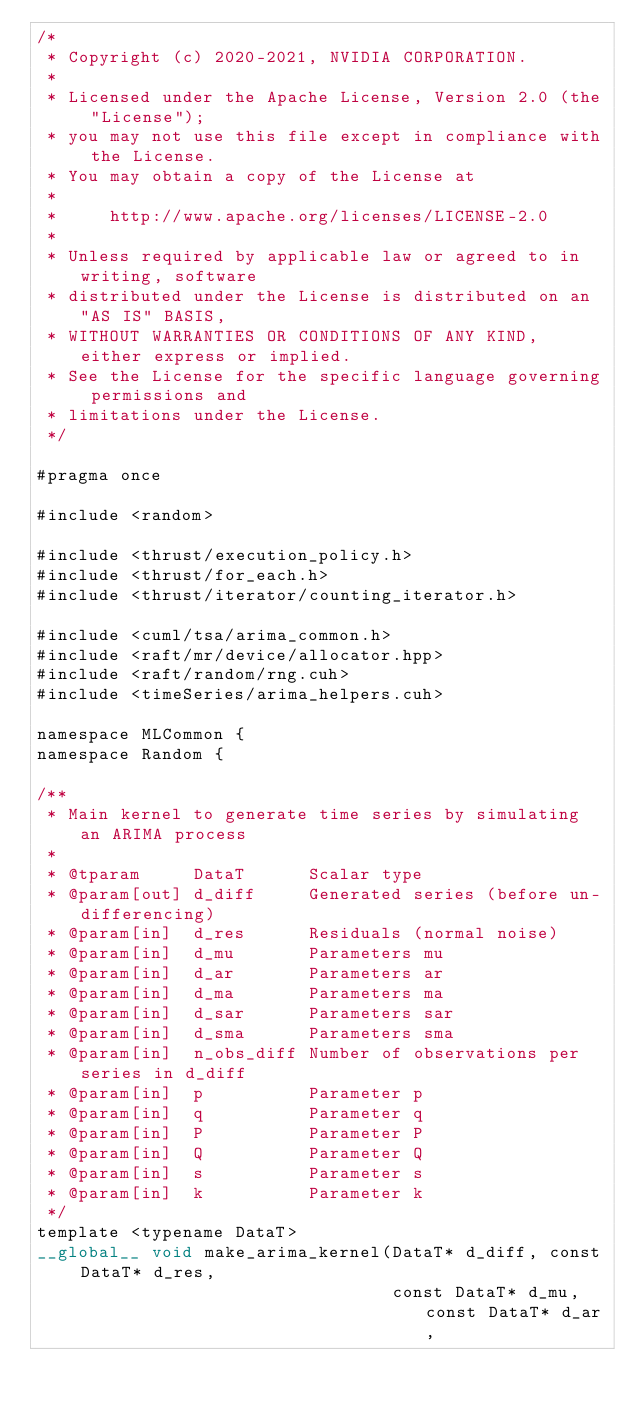<code> <loc_0><loc_0><loc_500><loc_500><_Cuda_>/*
 * Copyright (c) 2020-2021, NVIDIA CORPORATION.
 *
 * Licensed under the Apache License, Version 2.0 (the "License");
 * you may not use this file except in compliance with the License.
 * You may obtain a copy of the License at
 *
 *     http://www.apache.org/licenses/LICENSE-2.0
 *
 * Unless required by applicable law or agreed to in writing, software
 * distributed under the License is distributed on an "AS IS" BASIS,
 * WITHOUT WARRANTIES OR CONDITIONS OF ANY KIND, either express or implied.
 * See the License for the specific language governing permissions and
 * limitations under the License.
 */

#pragma once

#include <random>

#include <thrust/execution_policy.h>
#include <thrust/for_each.h>
#include <thrust/iterator/counting_iterator.h>

#include <cuml/tsa/arima_common.h>
#include <raft/mr/device/allocator.hpp>
#include <raft/random/rng.cuh>
#include <timeSeries/arima_helpers.cuh>

namespace MLCommon {
namespace Random {

/**
 * Main kernel to generate time series by simulating an ARIMA process
 *
 * @tparam     DataT      Scalar type
 * @param[out] d_diff     Generated series (before un-differencing)
 * @param[in]  d_res      Residuals (normal noise)
 * @param[in]  d_mu       Parameters mu
 * @param[in]  d_ar       Parameters ar
 * @param[in]  d_ma       Parameters ma
 * @param[in]  d_sar      Parameters sar
 * @param[in]  d_sma      Parameters sma
 * @param[in]  n_obs_diff Number of observations per series in d_diff
 * @param[in]  p          Parameter p
 * @param[in]  q          Parameter q
 * @param[in]  P          Parameter P
 * @param[in]  Q          Parameter Q
 * @param[in]  s          Parameter s
 * @param[in]  k          Parameter k
 */
template <typename DataT>
__global__ void make_arima_kernel(DataT* d_diff, const DataT* d_res,
                                  const DataT* d_mu, const DataT* d_ar,</code> 